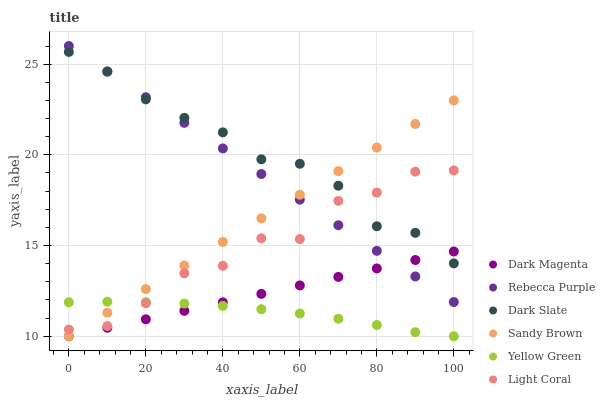Does Yellow Green have the minimum area under the curve?
Answer yes or no. Yes. Does Dark Slate have the maximum area under the curve?
Answer yes or no. Yes. Does Light Coral have the minimum area under the curve?
Answer yes or no. No. Does Light Coral have the maximum area under the curve?
Answer yes or no. No. Is Dark Magenta the smoothest?
Answer yes or no. Yes. Is Light Coral the roughest?
Answer yes or no. Yes. Is Dark Slate the smoothest?
Answer yes or no. No. Is Dark Slate the roughest?
Answer yes or no. No. Does Yellow Green have the lowest value?
Answer yes or no. Yes. Does Light Coral have the lowest value?
Answer yes or no. No. Does Rebecca Purple have the highest value?
Answer yes or no. Yes. Does Light Coral have the highest value?
Answer yes or no. No. Is Yellow Green less than Dark Slate?
Answer yes or no. Yes. Is Dark Slate greater than Yellow Green?
Answer yes or no. Yes. Does Rebecca Purple intersect Sandy Brown?
Answer yes or no. Yes. Is Rebecca Purple less than Sandy Brown?
Answer yes or no. No. Is Rebecca Purple greater than Sandy Brown?
Answer yes or no. No. Does Yellow Green intersect Dark Slate?
Answer yes or no. No. 